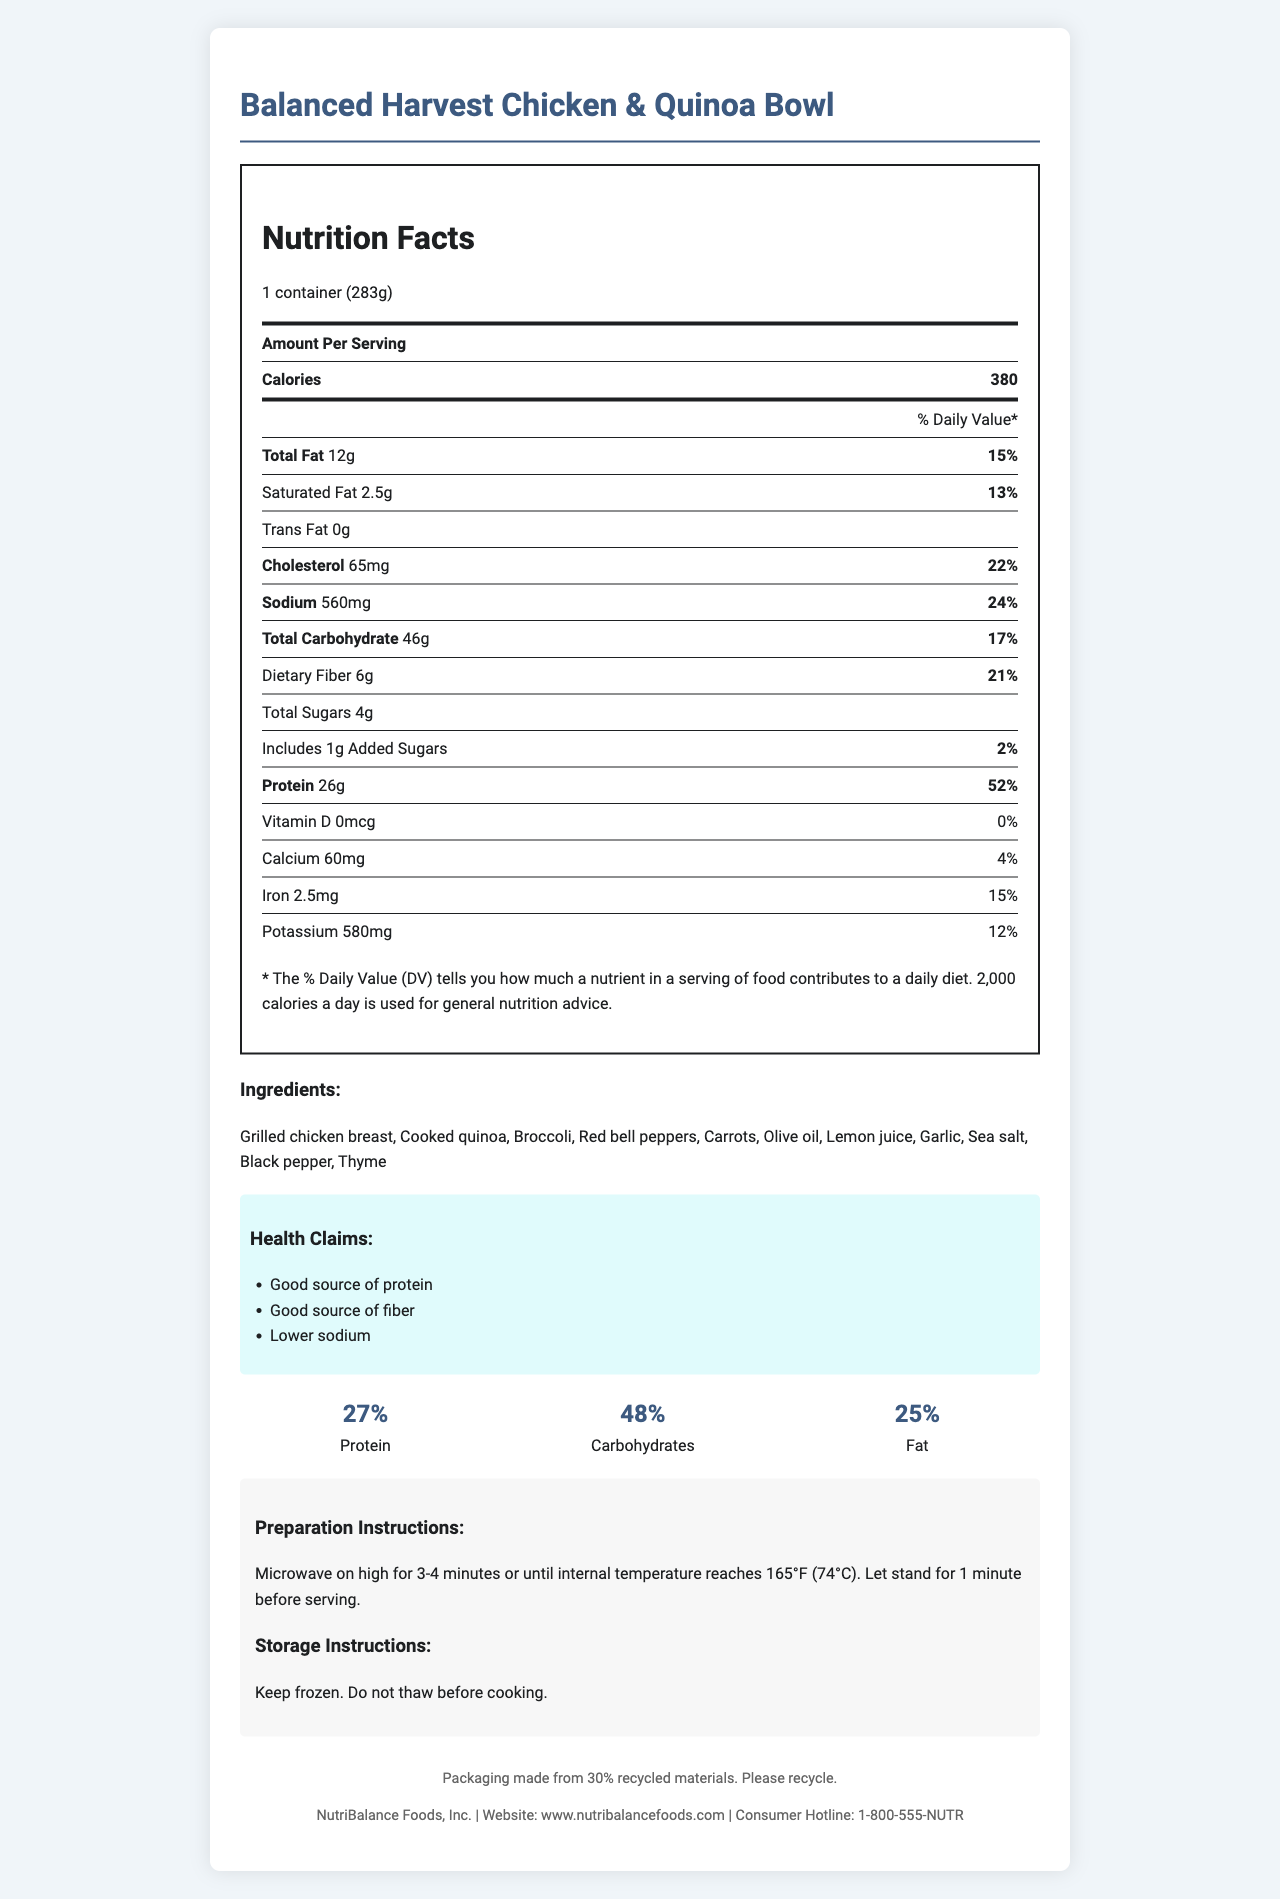what is the serving size? The serving size is clearly stated at the beginning of the nutrition label as "1 container (283g)".
Answer: 1 container (283g) How many calories are in one serving? The number of calories per serving is listed as 380 on the nutrition label.
Answer: 380 What percentage of the daily value of protein does this meal provide? According to the nutrition label, the meal provides 52% of the daily value for protein.
Answer: 52% What are the macronutrient percentages for protein, carbohydrates, and fat? These percentages are broken down in the macronutrient balance section under the nutrition facts.
Answer: Protein: 27%, Carbohydrates: 48%, Fat: 25% How much sodium is in one serving? The sodium content per serving is specified as 560 mg on the nutrition label.
Answer: 560 mg Which of the following is not included in the ingredients? A. Olive oil B. Broccoli C. Soy sauce D. Lemon juice The list of ingredients does not include soy sauce; it includes olive oil, broccoli, and lemon juice.
Answer: C. Soy sauce How much dietary fiber is in this meal? A. 6g B. 4g C. 2g D. 1g The dietary fiber content is listed as 6g on the nutrition label.
Answer: A. 6g Is this meal a good source of fiber? The label claims the meal is a "Good source of fiber," and it also provides 21% of the daily value for dietary fiber.
Answer: Yes Does the meal contain any trans fat? The nutrition label explicitly states that the trans fat amount is 0g.
Answer: No Summarize the key nutritional information and health claims presented in this document. The document highlights the nutritional breakdown, including macronutrient distribution, and detailed contents of fats, carbs, sugars, proteins, and essential nutrients. It also emphasizes health benefits such as being a good source of protein and fiber while maintaining lower sodium levels.
Answer: The Balanced Harvest Chicken & Quinoa Bowl provides a balanced mix of macronutrients with 380 calories per serving, 12g of total fat, 2.5g of saturated fat, 46g of carbohydrates, 6g of dietary fiber, 4g of total sugars (1g added sugars), and 26g of protein. It also contains 65mg of cholesterol, 560mg of sodium, along with vitamins and minerals such as calcium, iron, and potassium. The meal is marketed as a good source of protein and fiber and has a relatively lower sodium content. What is the main source of protein in this meal? The first ingredient listed is grilled chicken breast, which is a primary protein source.
Answer: Grilled chicken breast Are there any allergens listed for this meal? The document states that there are no allergens listed for this meal.
Answer: None Has the packaging been made from recycled materials? The document mentions that the packaging is made from 30% recycled materials.
Answer: Yes What preparation method is recommended for this meal? The preparation instructions specify using a microwave on high for 3-4 minutes until the internal temperature reaches 165°F.
Answer: Microwave on high for 3-4 minutes or until internal temperature reaches 165°F (74°C). Let stand for 1 minute before serving. What organization provides the nutrition information and support services for this product? The company information section states that NutriBalance Foods, Inc. is responsible for the product and provides a website and consumer hotline for support services.
Answer: NutriBalance Foods, Inc. What is the cholesterol content in one serving? The nutrition label indicates that each serving contains 65 mg of cholesterol.
Answer: 65 mg How much potassium does the meal contain? The potassium content listed on the nutrition label is 580 mg.
Answer: 580 mg Can this meal be thawed before cooking? The storage instructions clearly state, "Do not thaw before cooking".
Answer: No Which vitamin or mineral present has the highest daily value percentage? Among all listed vitamins and minerals, protein stands out with the highest daily value percentage of 52%.
Answer: Protein at 52% What percent of the daily value for total carbohydrates does this meal provide? The nutrition facts label shows that the total carbohydrates represent 17% of the daily value.
Answer: 17% Can you tell the exact preparation time required based on the visual information? The document provides a range of 3-4 minutes for microwave preparation but does not specify an exact time for readiness.
Answer: Not exactly 